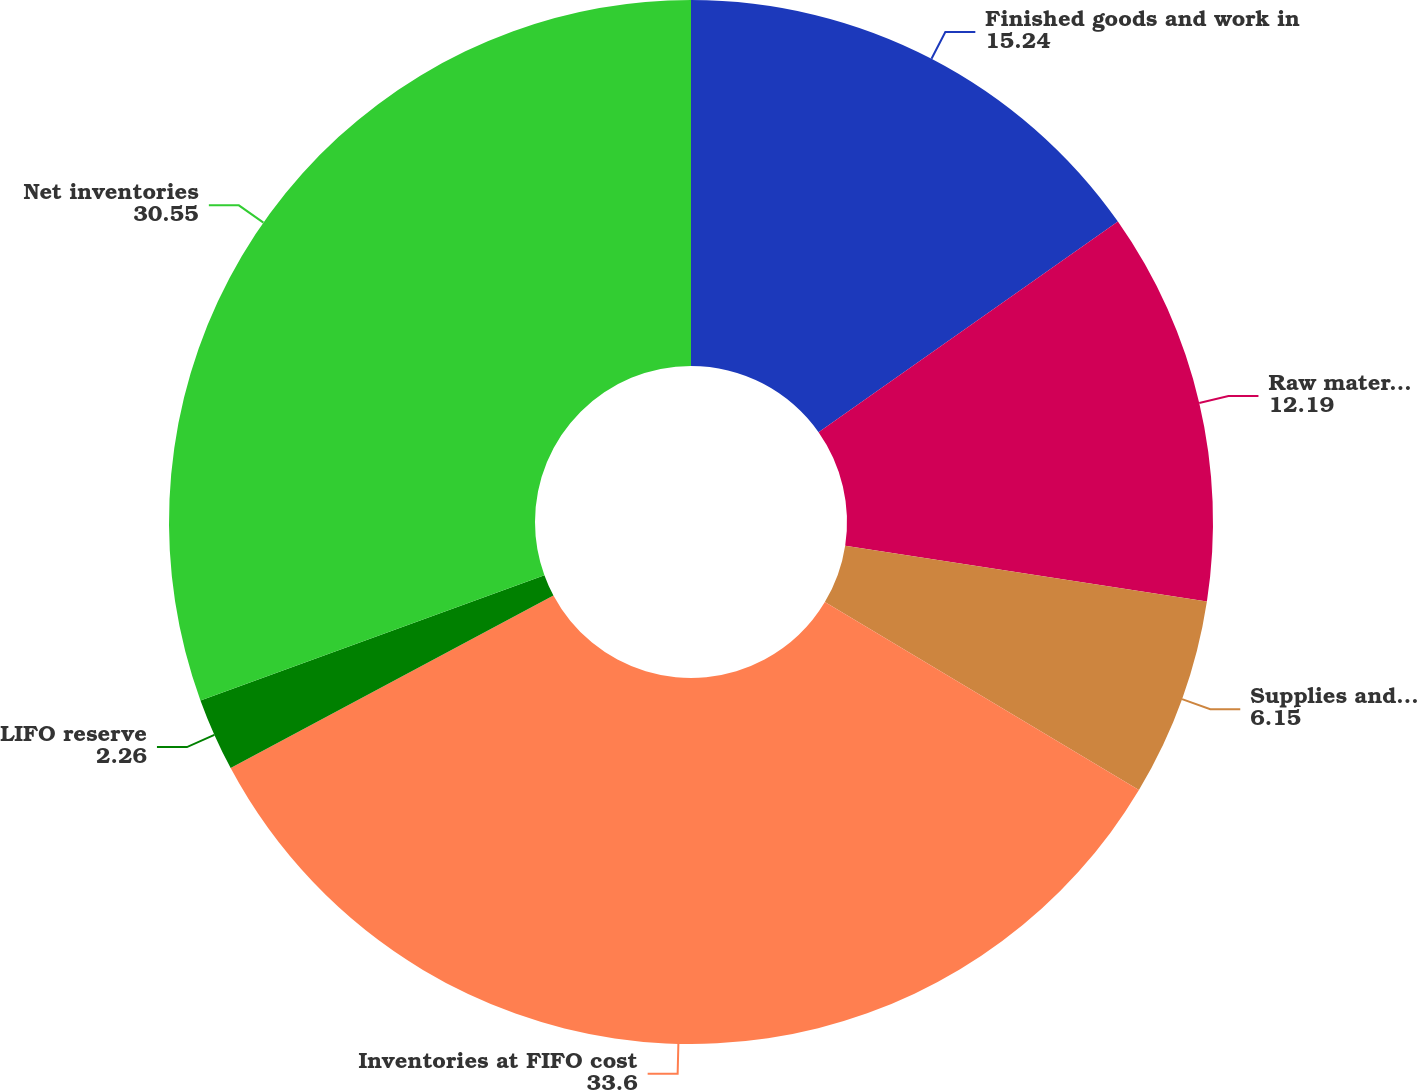<chart> <loc_0><loc_0><loc_500><loc_500><pie_chart><fcel>Finished goods and work in<fcel>Raw materials<fcel>Supplies and spare parts<fcel>Inventories at FIFO cost<fcel>LIFO reserve<fcel>Net inventories<nl><fcel>15.24%<fcel>12.19%<fcel>6.15%<fcel>33.6%<fcel>2.26%<fcel>30.55%<nl></chart> 